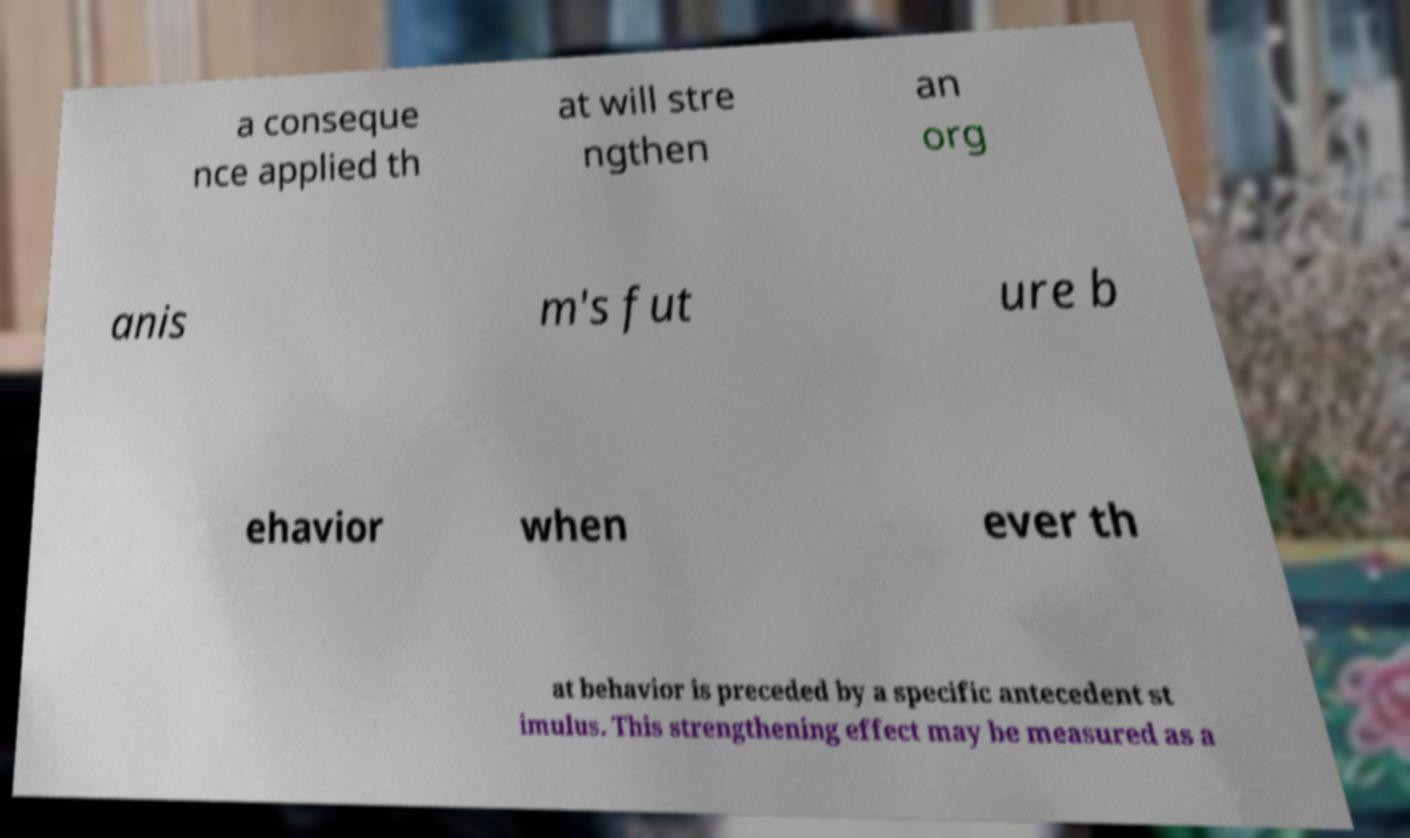I need the written content from this picture converted into text. Can you do that? a conseque nce applied th at will stre ngthen an org anis m's fut ure b ehavior when ever th at behavior is preceded by a specific antecedent st imulus. This strengthening effect may be measured as a 